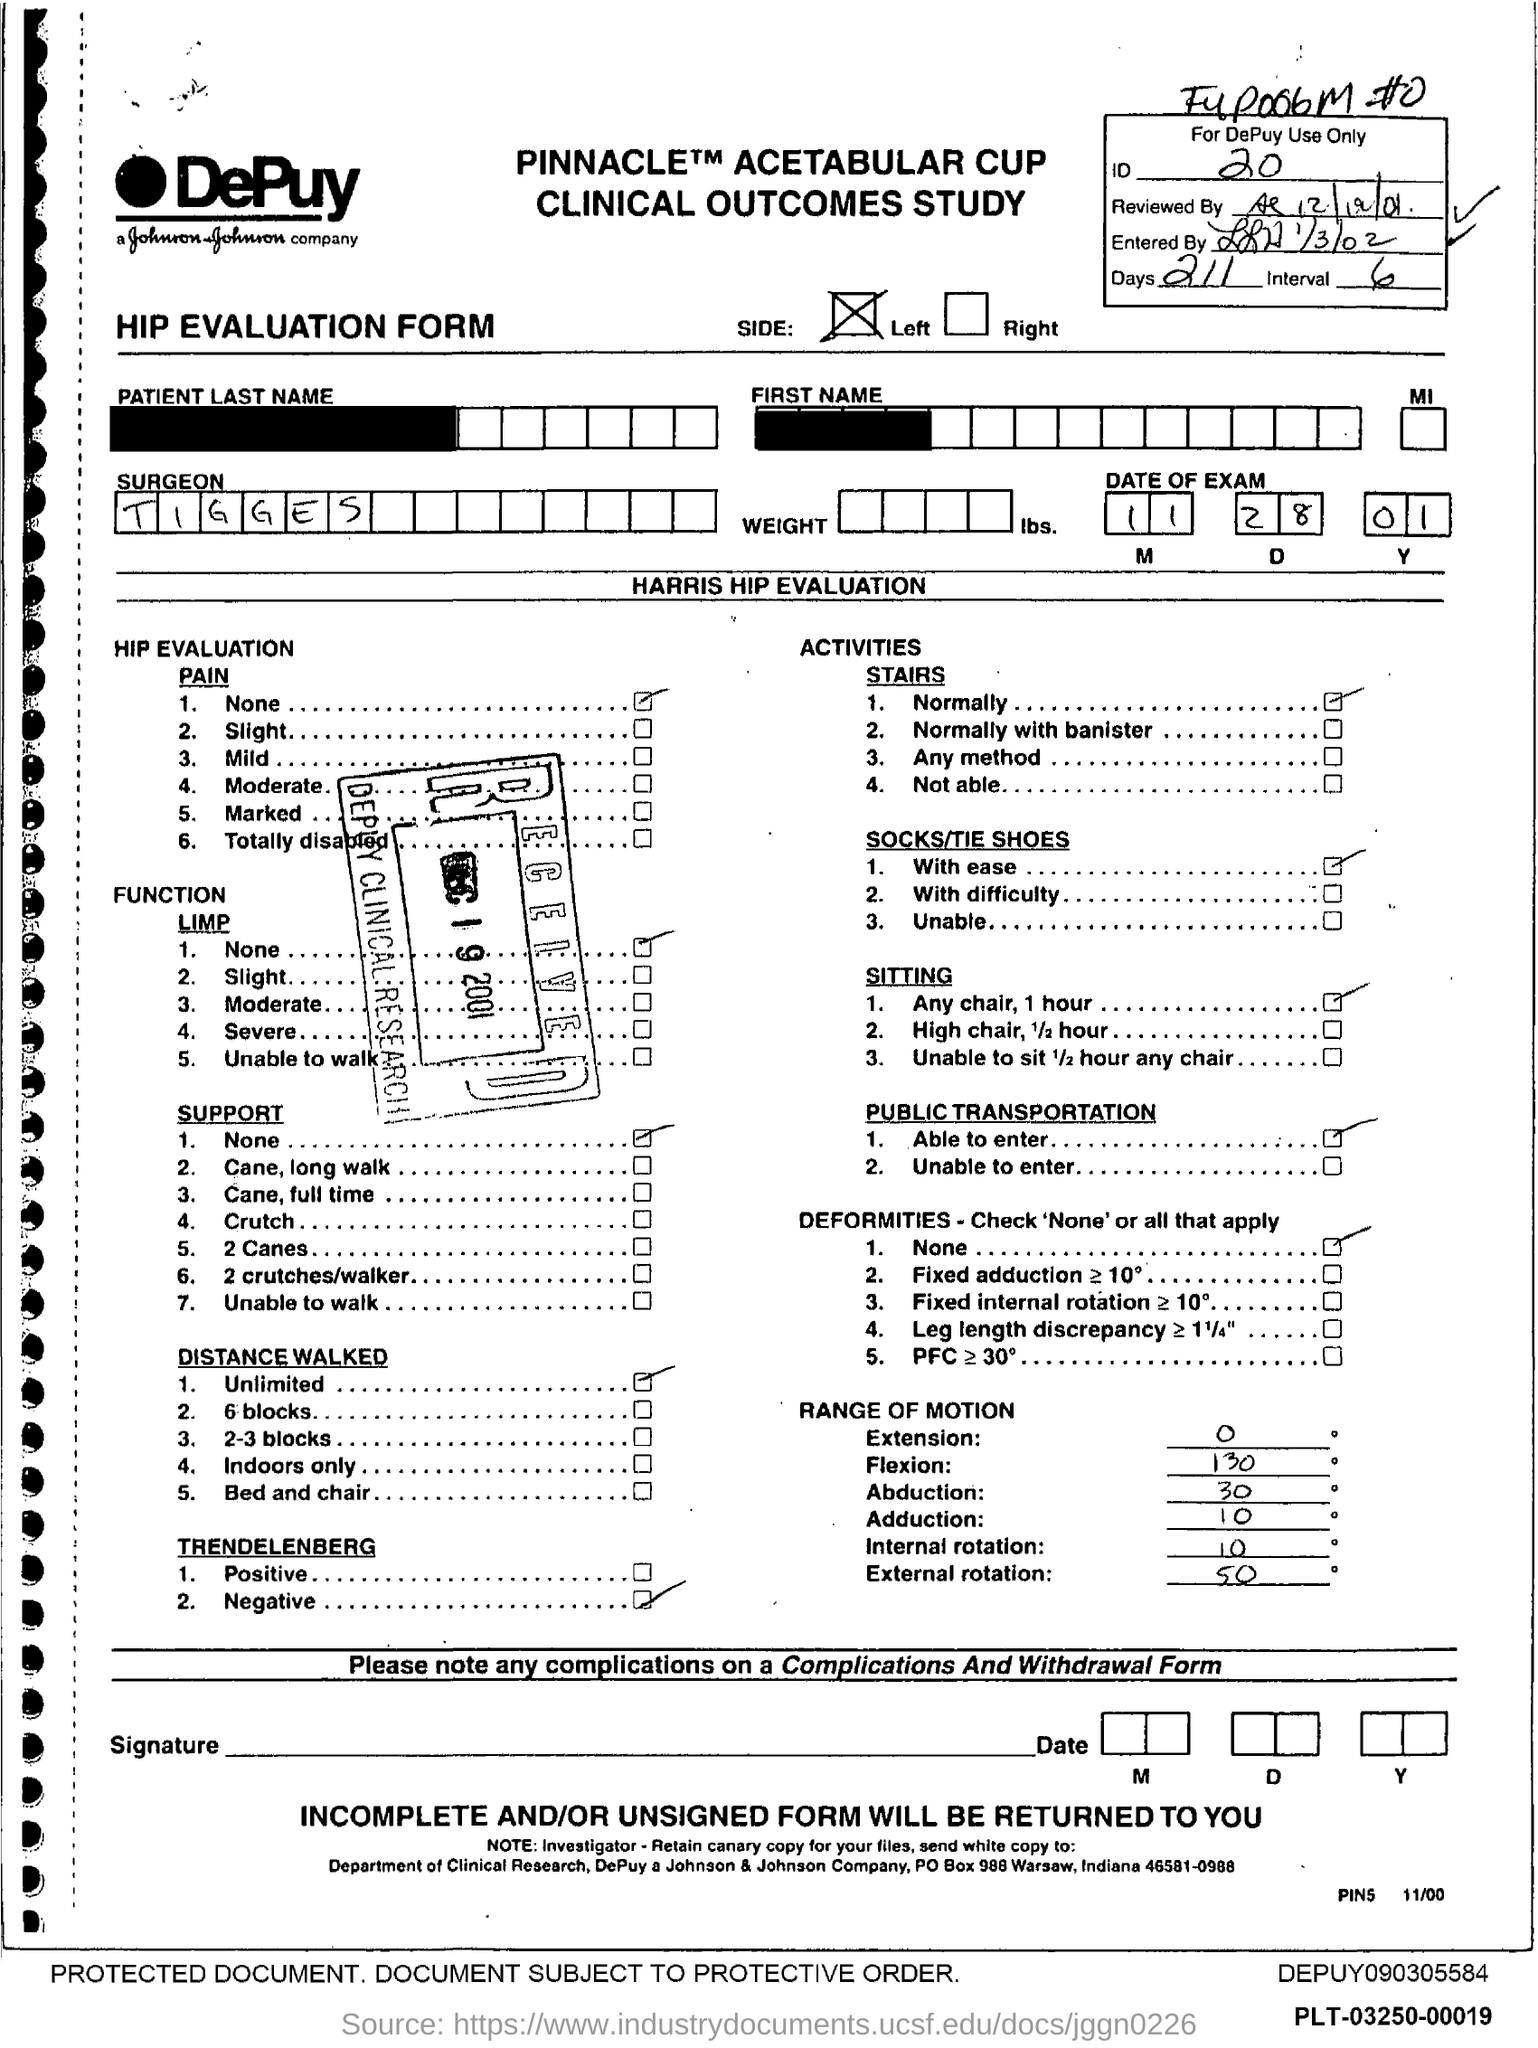What is the ID Number?
Provide a succinct answer. 20. What is the number of days?
Offer a very short reply. 211. What is the name of the Surgeon?
Provide a short and direct response. Tigges. 